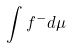<formula> <loc_0><loc_0><loc_500><loc_500>\int f ^ { - } d \mu</formula> 